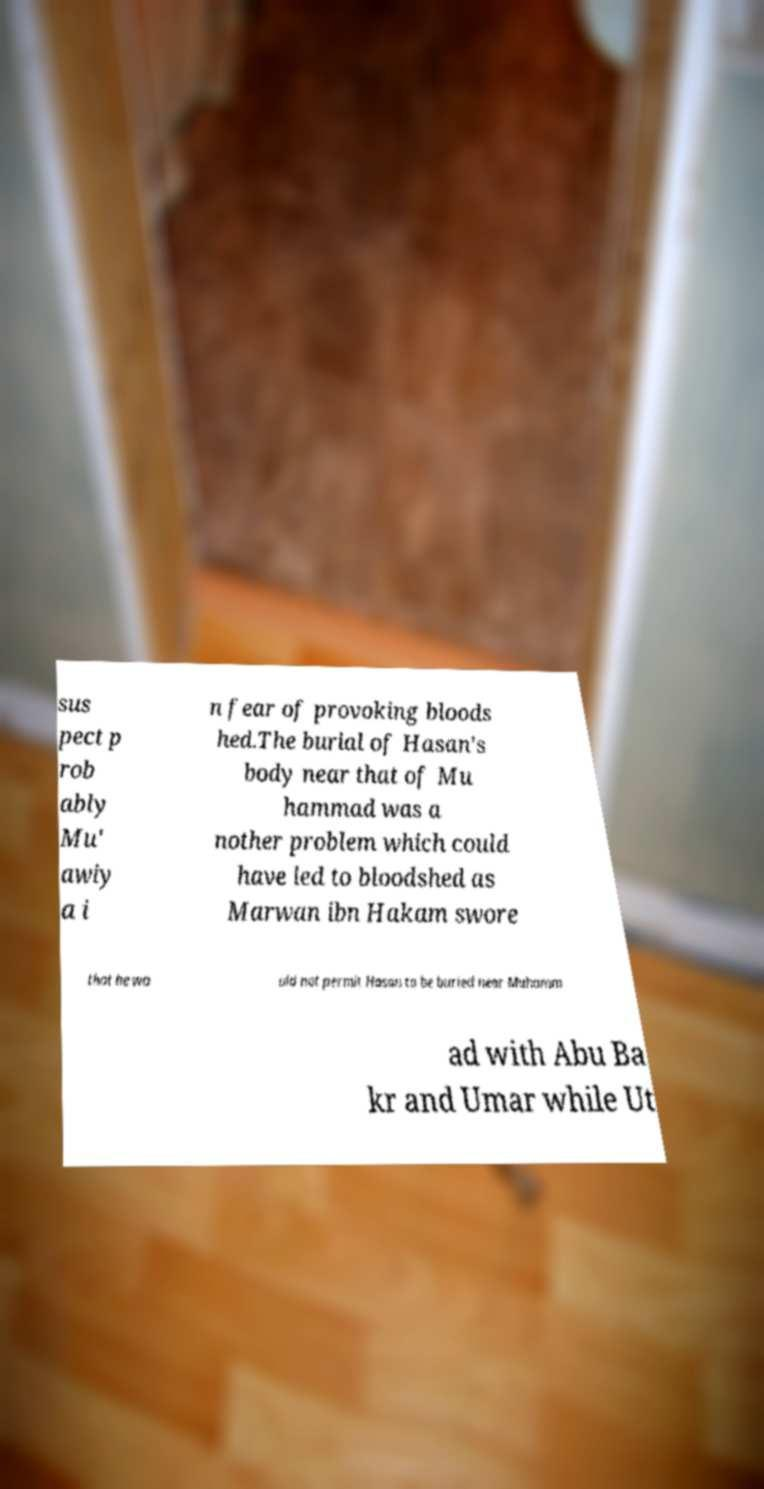There's text embedded in this image that I need extracted. Can you transcribe it verbatim? sus pect p rob ably Mu' awiy a i n fear of provoking bloods hed.The burial of Hasan's body near that of Mu hammad was a nother problem which could have led to bloodshed as Marwan ibn Hakam swore that he wo uld not permit Hasan to be buried near Muhamm ad with Abu Ba kr and Umar while Ut 